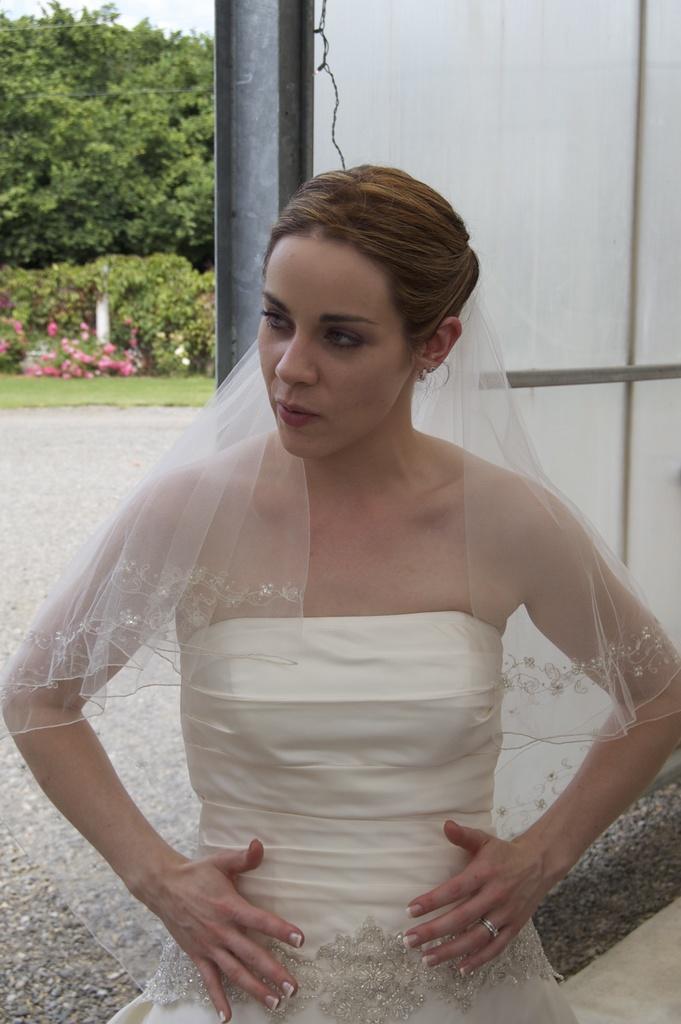Please provide a concise description of this image. Here, at the middle we can see woman standing, in the background there is a pole and there are some green color plants and trees. 